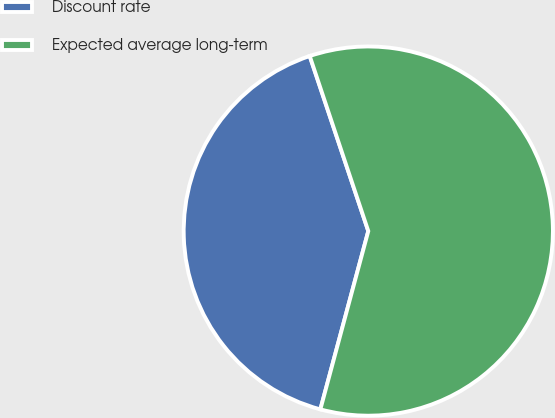<chart> <loc_0><loc_0><loc_500><loc_500><pie_chart><fcel>Discount rate<fcel>Expected average long-term<nl><fcel>40.68%<fcel>59.32%<nl></chart> 